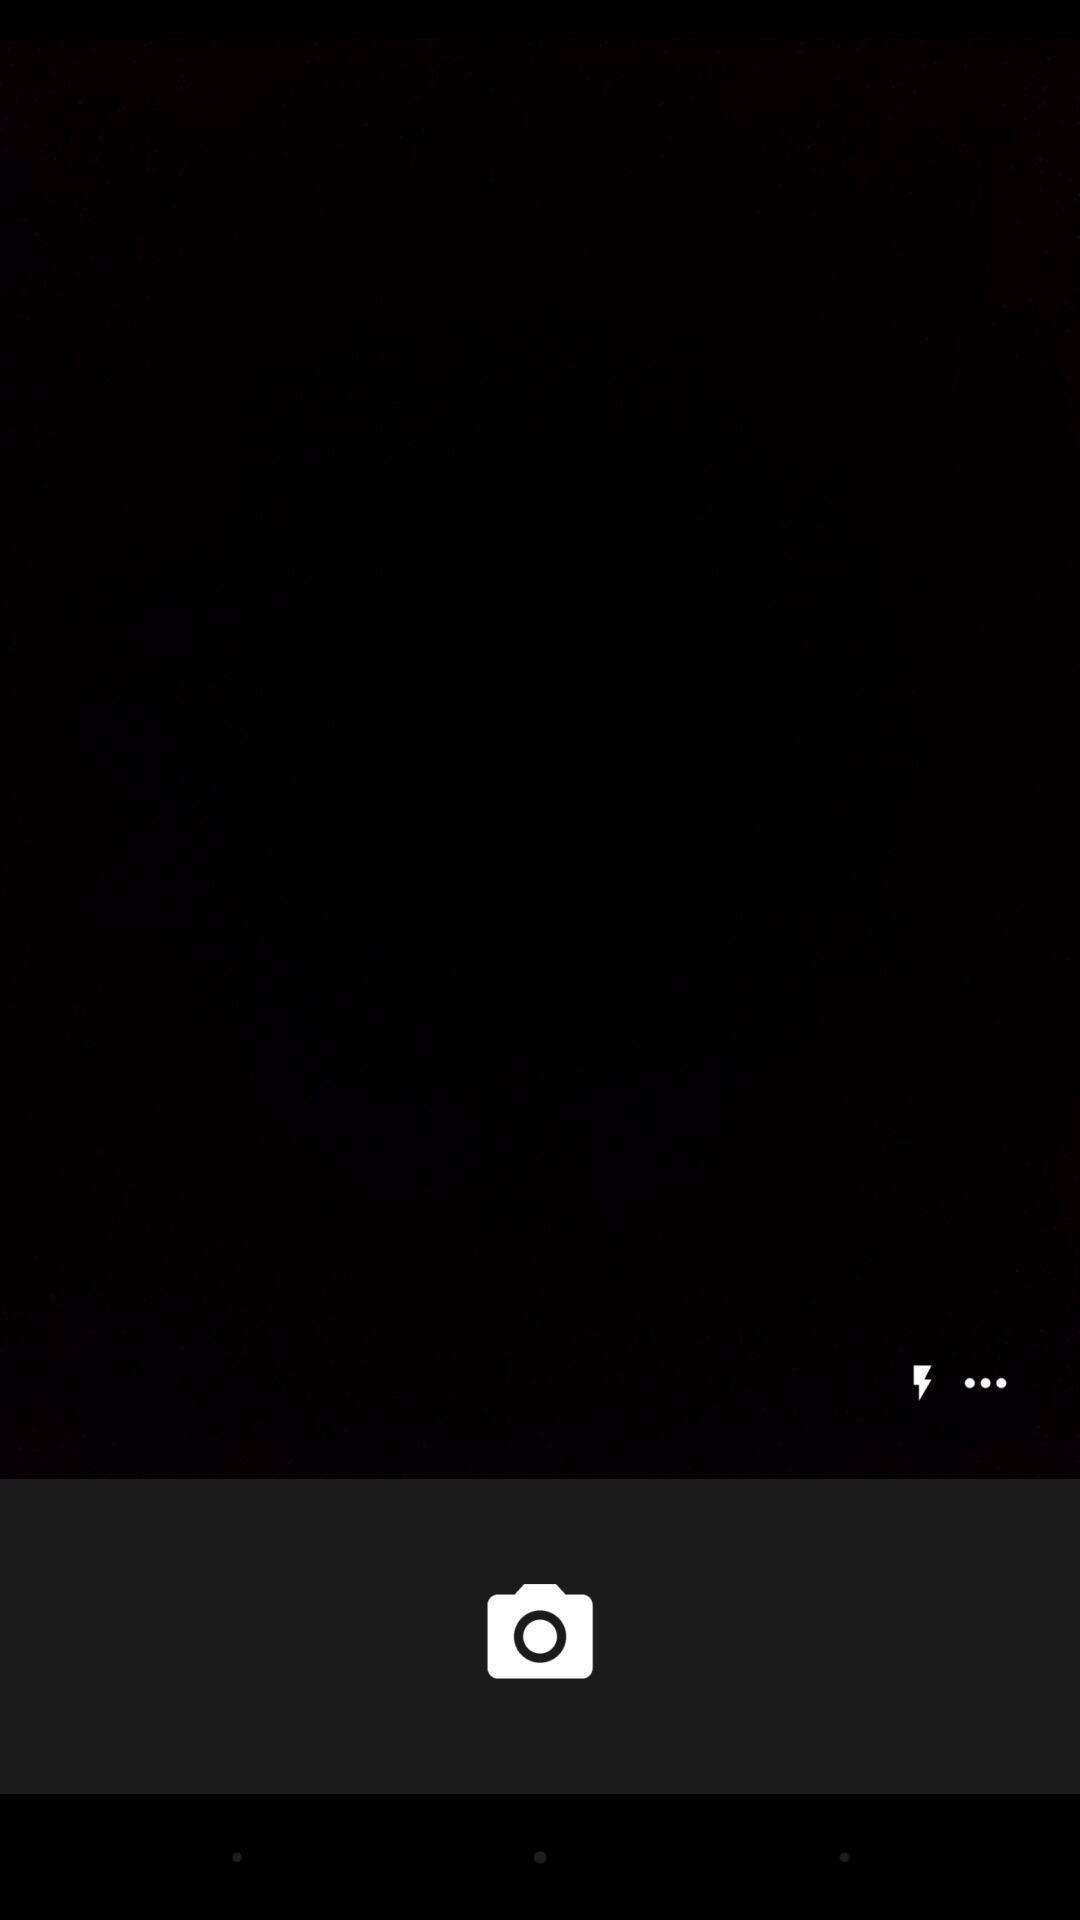Tell me about the visual elements in this screen capture. Page showing of camera icon for calling app. 